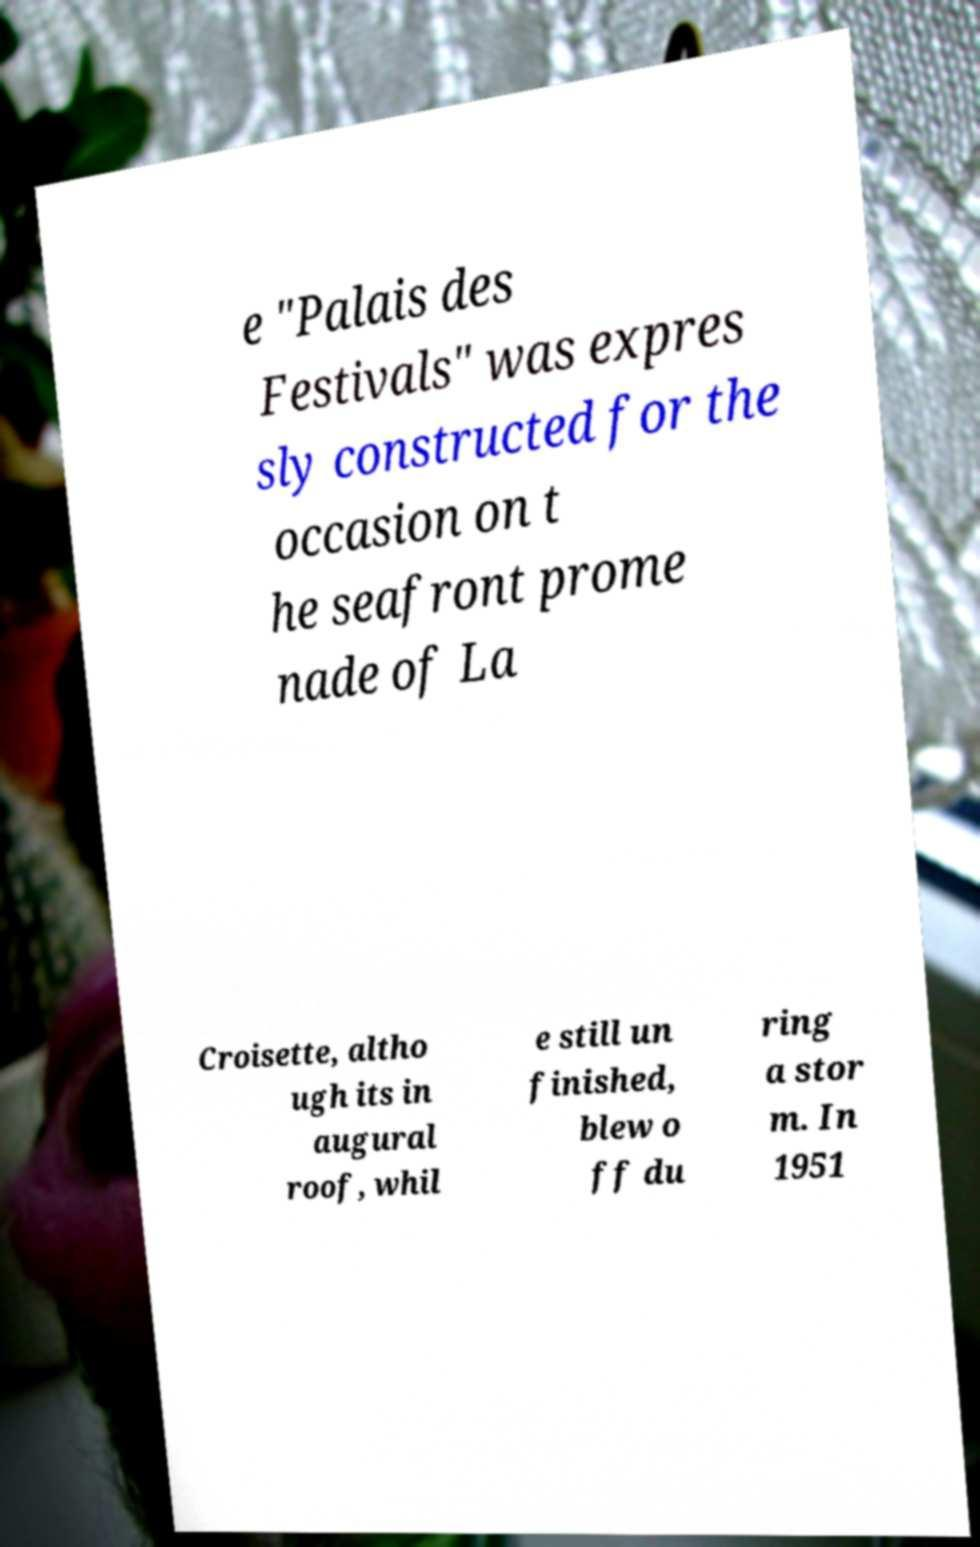Could you extract and type out the text from this image? e "Palais des Festivals" was expres sly constructed for the occasion on t he seafront prome nade of La Croisette, altho ugh its in augural roof, whil e still un finished, blew o ff du ring a stor m. In 1951 